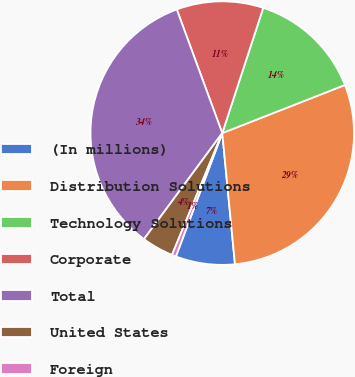Convert chart to OTSL. <chart><loc_0><loc_0><loc_500><loc_500><pie_chart><fcel>(In millions)<fcel>Distribution Solutions<fcel>Technology Solutions<fcel>Corporate<fcel>Total<fcel>United States<fcel>Foreign<nl><fcel>7.26%<fcel>29.41%<fcel>14.02%<fcel>10.64%<fcel>34.27%<fcel>3.89%<fcel>0.51%<nl></chart> 